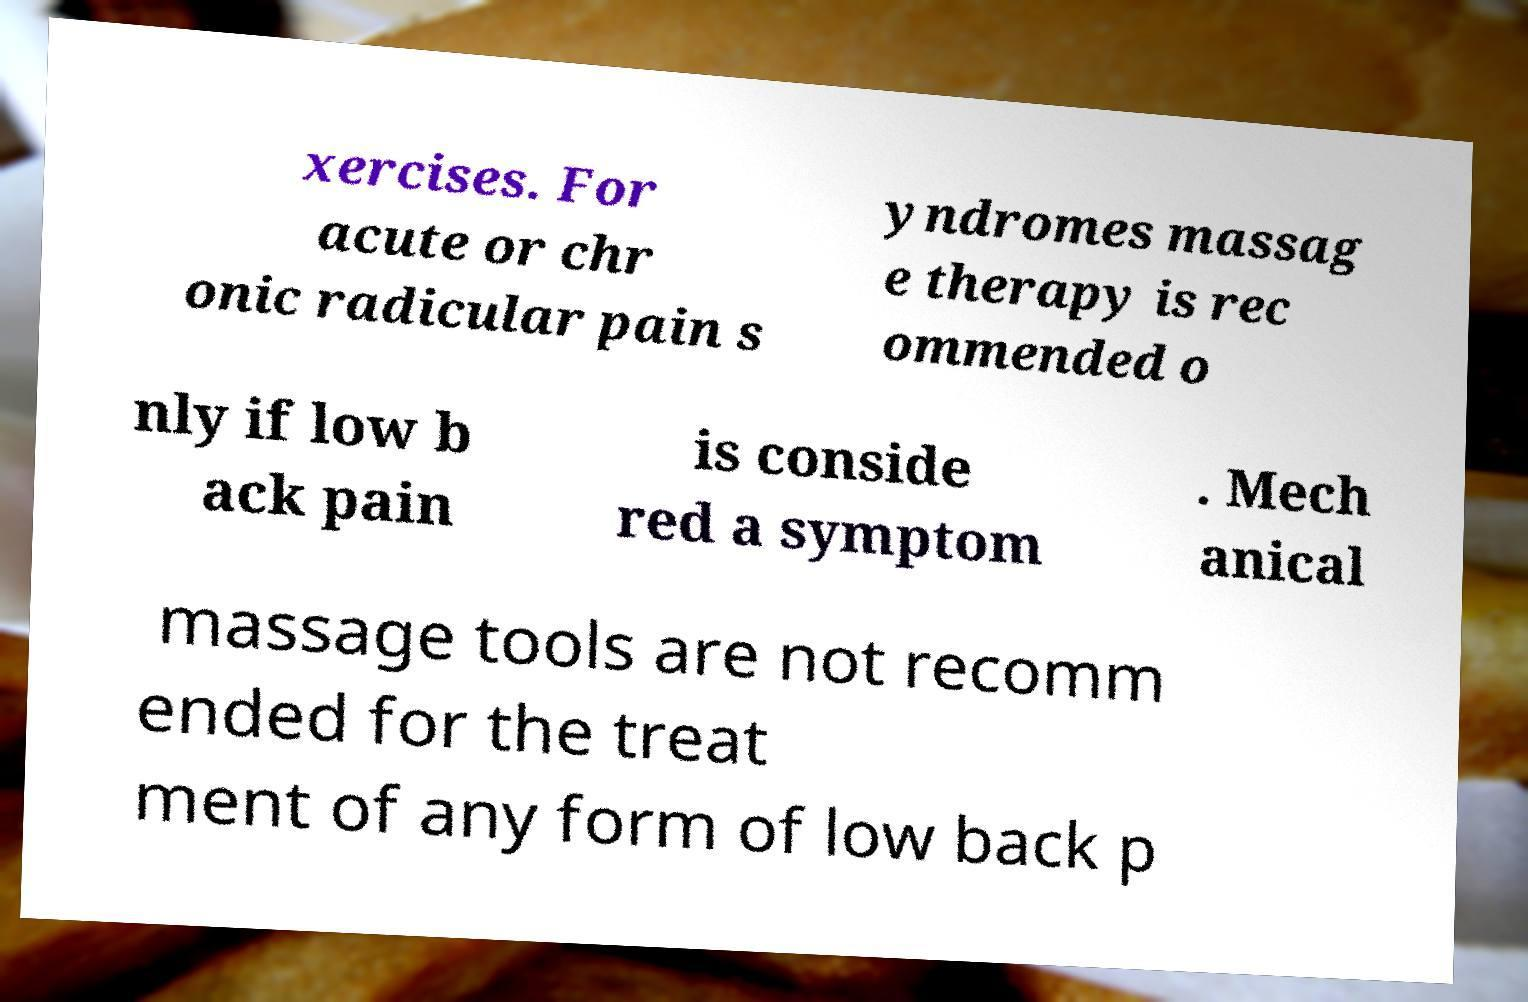Can you read and provide the text displayed in the image?This photo seems to have some interesting text. Can you extract and type it out for me? xercises. For acute or chr onic radicular pain s yndromes massag e therapy is rec ommended o nly if low b ack pain is conside red a symptom . Mech anical massage tools are not recomm ended for the treat ment of any form of low back p 